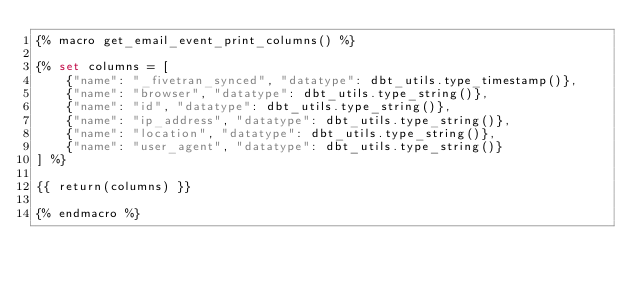<code> <loc_0><loc_0><loc_500><loc_500><_SQL_>{% macro get_email_event_print_columns() %}

{% set columns = [
    {"name": "_fivetran_synced", "datatype": dbt_utils.type_timestamp()},
    {"name": "browser", "datatype": dbt_utils.type_string()},
    {"name": "id", "datatype": dbt_utils.type_string()},
    {"name": "ip_address", "datatype": dbt_utils.type_string()},
    {"name": "location", "datatype": dbt_utils.type_string()},
    {"name": "user_agent", "datatype": dbt_utils.type_string()}
] %}

{{ return(columns) }}

{% endmacro %}
</code> 